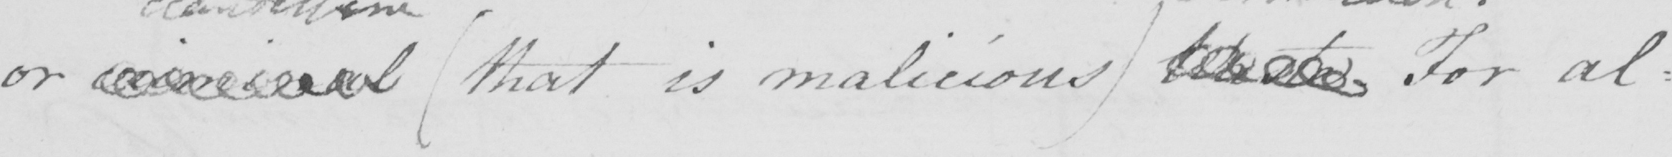Transcribe the text shown in this historical manuscript line. or criminal  ( that is malicious )  Waste . For al= 